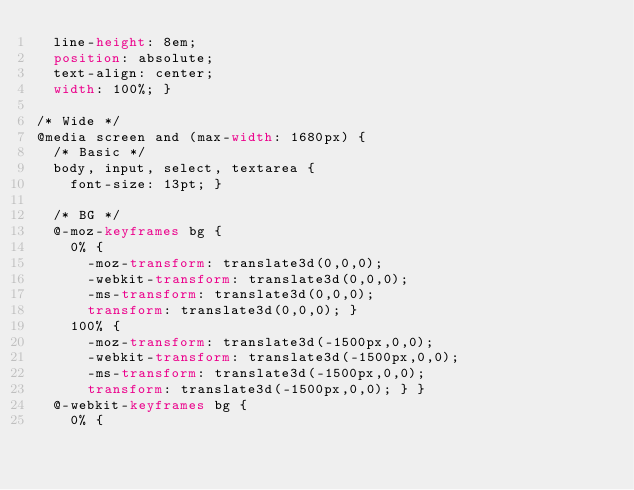<code> <loc_0><loc_0><loc_500><loc_500><_CSS_>  line-height: 8em;
  position: absolute;
  text-align: center;
  width: 100%; }

/* Wide */
@media screen and (max-width: 1680px) {
  /* Basic */
  body, input, select, textarea {
    font-size: 13pt; }

  /* BG */
  @-moz-keyframes bg {
    0% {
      -moz-transform: translate3d(0,0,0);
      -webkit-transform: translate3d(0,0,0);
      -ms-transform: translate3d(0,0,0);
      transform: translate3d(0,0,0); }
    100% {
      -moz-transform: translate3d(-1500px,0,0);
      -webkit-transform: translate3d(-1500px,0,0);
      -ms-transform: translate3d(-1500px,0,0);
      transform: translate3d(-1500px,0,0); } }
  @-webkit-keyframes bg {
    0% {</code> 